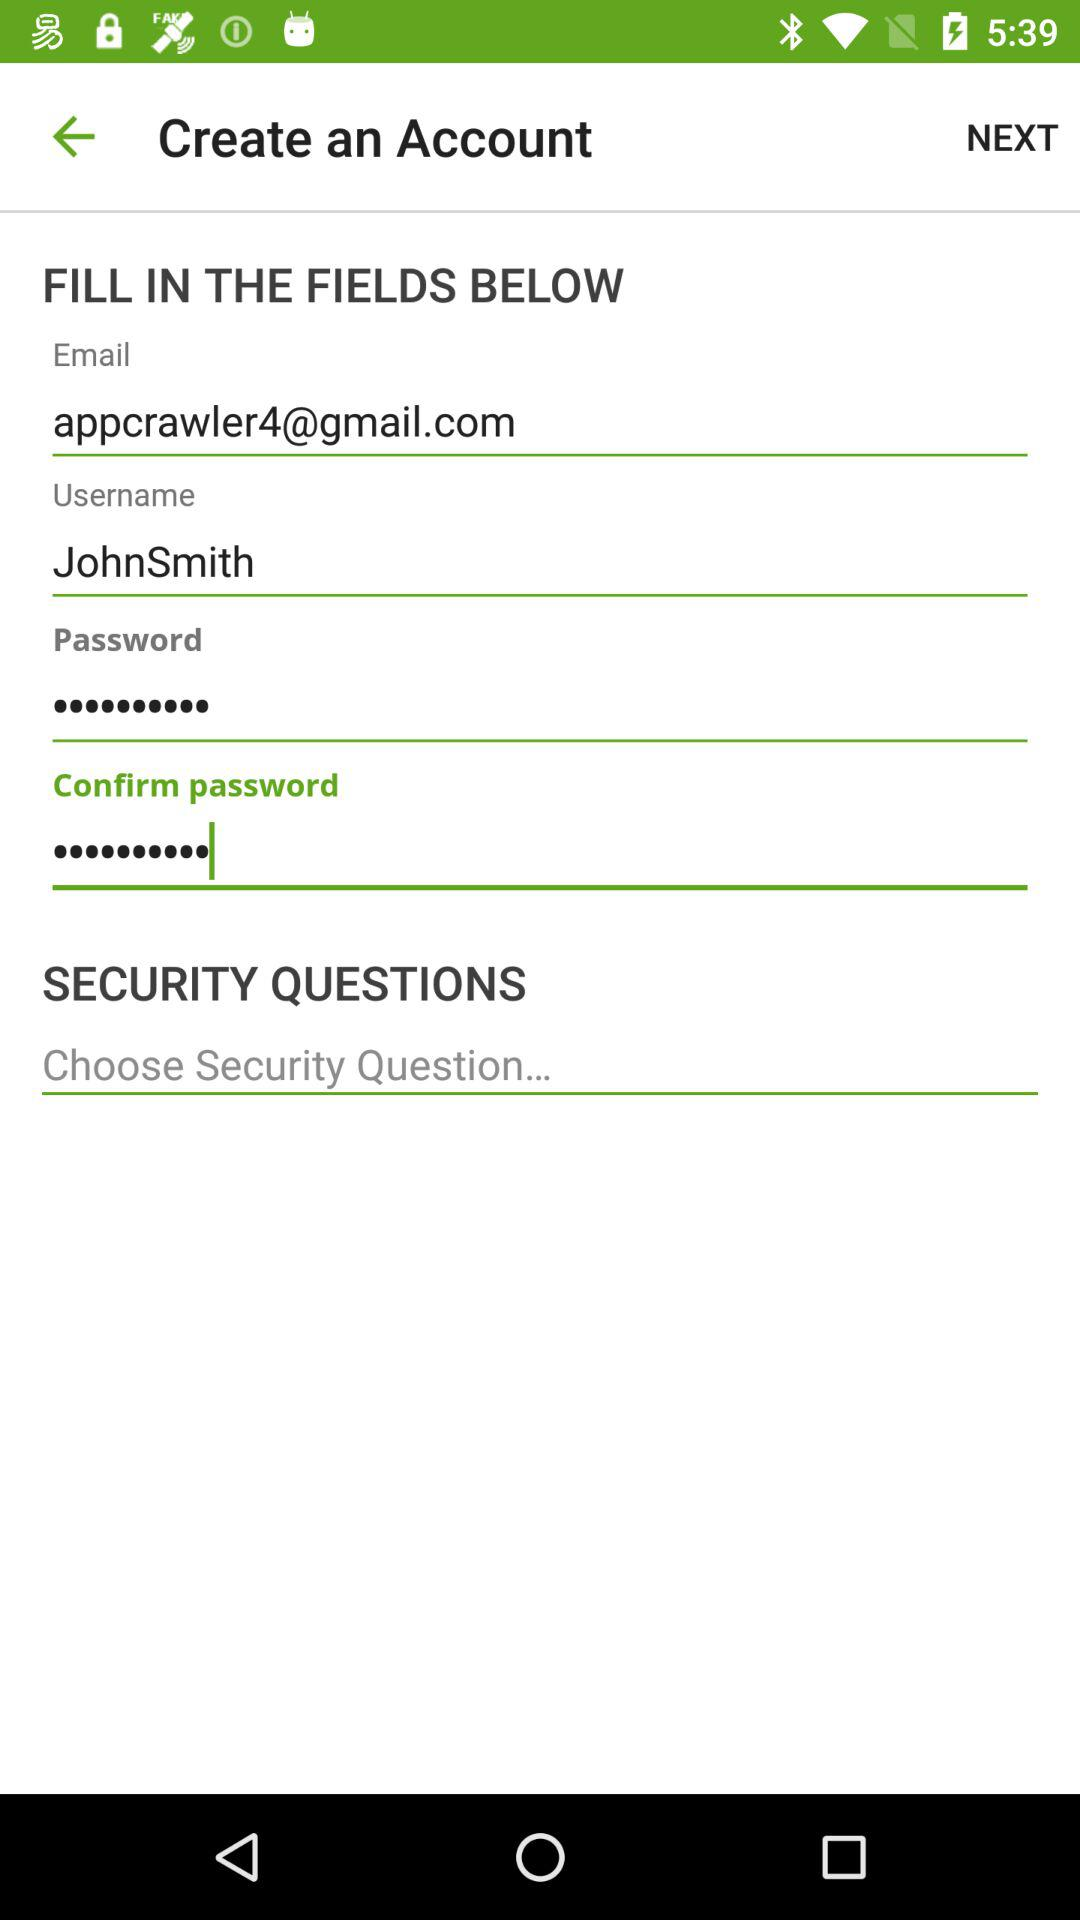How many security questions are there?
Answer the question using a single word or phrase. 1 